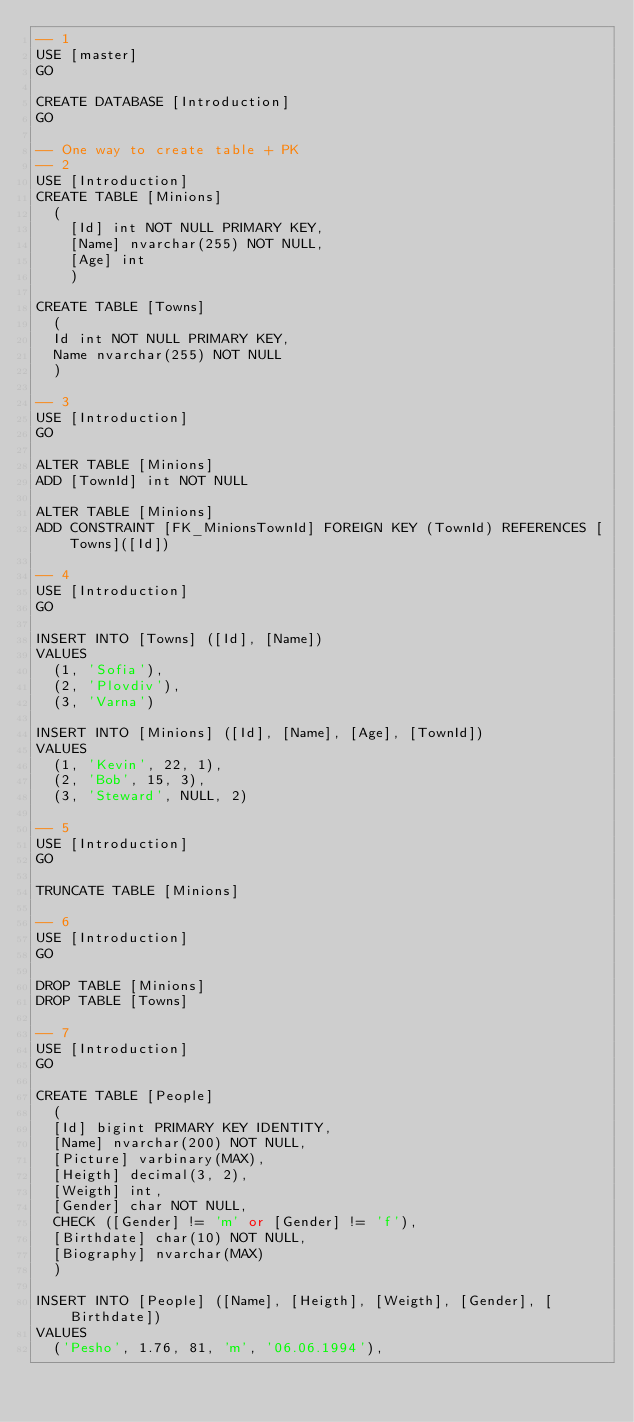<code> <loc_0><loc_0><loc_500><loc_500><_SQL_>-- 1
USE [master]
GO

CREATE DATABASE [Introduction]
GO

-- One way to create table + PK
-- 2
USE [Introduction]
CREATE TABLE [Minions] 
	(
    [Id] int NOT NULL PRIMARY KEY,
    [Name] nvarchar(255) NOT NULL,
    [Age] int
    )

CREATE TABLE [Towns]
	(
	Id int NOT NULL PRIMARY KEY,
	Name nvarchar(255) NOT NULL
	)

-- 3
USE [Introduction]
GO

ALTER TABLE [Minions]
ADD [TownId] int NOT NULL

ALTER TABLE [Minions]
ADD CONSTRAINT [FK_MinionsTownId] FOREIGN KEY (TownId) REFERENCES [Towns]([Id])

-- 4
USE [Introduction]
GO

INSERT INTO [Towns] ([Id], [Name]) 
VALUES
	(1, 'Sofia'),
	(2, 'Plovdiv'),
	(3, 'Varna')
	
INSERT INTO [Minions] ([Id], [Name], [Age], [TownId]) 
VALUES
	(1, 'Kevin', 22, 1),
	(2, 'Bob', 15, 3),
	(3, 'Steward', NULL, 2)

-- 5
USE [Introduction]
GO

TRUNCATE TABLE [Minions]

-- 6
USE [Introduction]
GO

DROP TABLE [Minions]
DROP TABLE [Towns]

-- 7
USE [Introduction]
GO

CREATE TABLE [People]
	(
	[Id] bigint PRIMARY KEY IDENTITY,
	[Name] nvarchar(200) NOT NULL,
	[Picture] varbinary(MAX),
	[Heigth] decimal(3, 2),
	[Weigth] int,
	[Gender] char NOT NULL,
	CHECK ([Gender] != 'm' or [Gender] != 'f'),
	[Birthdate] char(10) NOT NULL,
	[Biography] nvarchar(MAX)
	)

INSERT INTO [People] ([Name], [Heigth], [Weigth], [Gender], [Birthdate])
VALUES
	('Pesho', 1.76, 81, 'm', '06.06.1994'),</code> 